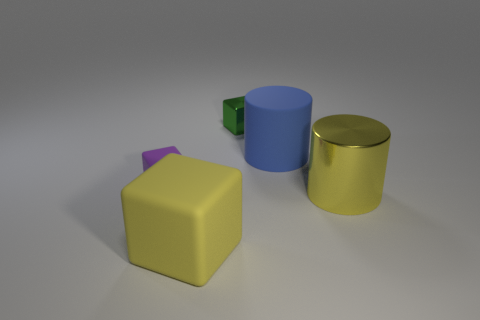Add 2 big yellow metallic cylinders. How many objects exist? 7 Subtract all cubes. How many objects are left? 2 Add 4 tiny blocks. How many tiny blocks are left? 6 Add 2 small objects. How many small objects exist? 4 Subtract 0 cyan spheres. How many objects are left? 5 Subtract all large blue blocks. Subtract all small shiny cubes. How many objects are left? 4 